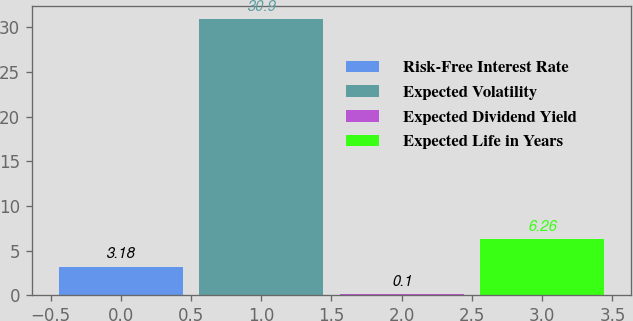Convert chart. <chart><loc_0><loc_0><loc_500><loc_500><bar_chart><fcel>Risk-Free Interest Rate<fcel>Expected Volatility<fcel>Expected Dividend Yield<fcel>Expected Life in Years<nl><fcel>3.18<fcel>30.9<fcel>0.1<fcel>6.26<nl></chart> 